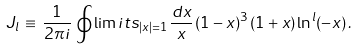<formula> <loc_0><loc_0><loc_500><loc_500>J _ { l } \, \equiv \, \frac { 1 } { 2 \pi i } \, \oint \lim i t s _ { | x | = 1 } \, \frac { d x } { x } \, ( 1 - x ) ^ { 3 } \, ( 1 + x ) \ln ^ { l } ( - x ) \, .</formula> 